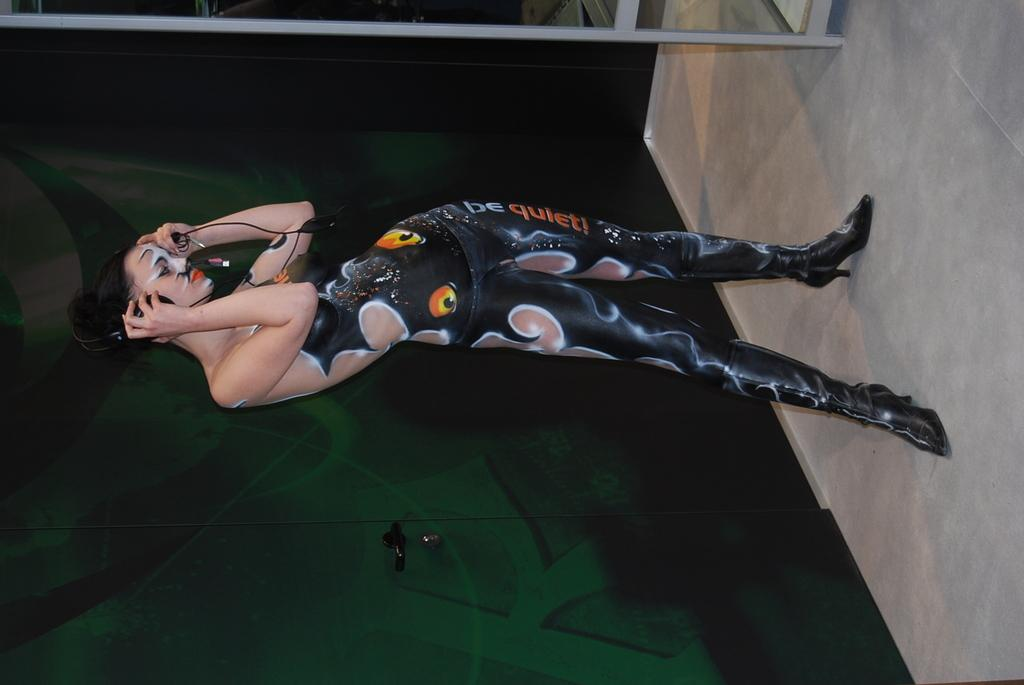Who is present in the image? There is a woman in the image. What is the woman wearing on her ears? The woman is wearing headphones. What surface is the woman standing on? The woman is standing on the floor. What object can be seen in the background? There is a stand in the background. What color is the board behind the woman? The board behind the woman is green. How many ducks are visible on the woman's chin in the image? There are no ducks visible on the woman's chin in the image. What type of trucks can be seen driving past the stand in the image? There are no trucks visible in the image; only a stand and a green color board are present. 